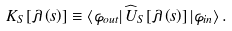Convert formula to latex. <formula><loc_0><loc_0><loc_500><loc_500>K _ { S } \left [ \lambda \left ( s \right ) \right ] \equiv \left \langle \varphi _ { o u t } \right | \widehat { U } _ { S } \left [ \lambda \left ( s \right ) \right ] \left | \varphi _ { i n } \right \rangle .</formula> 